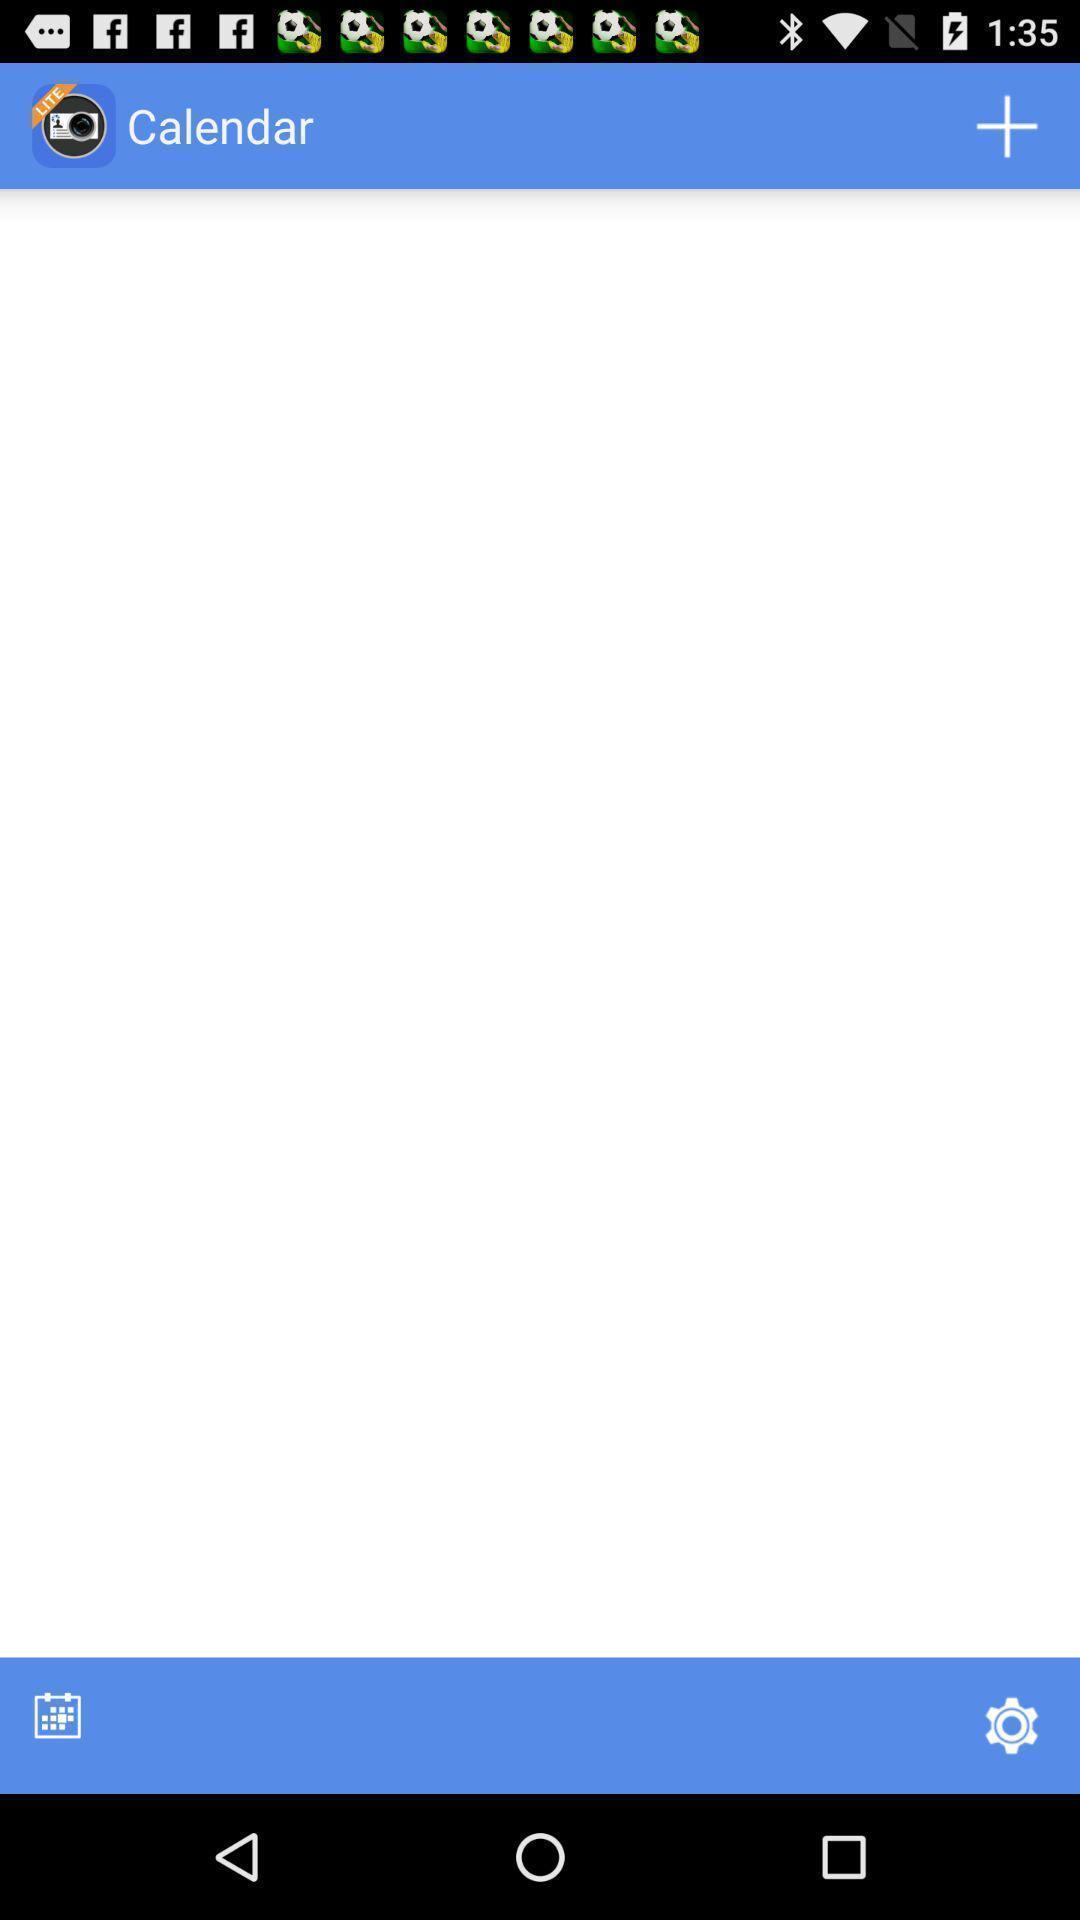Summarize the main components in this picture. Screen shows calendar page. 